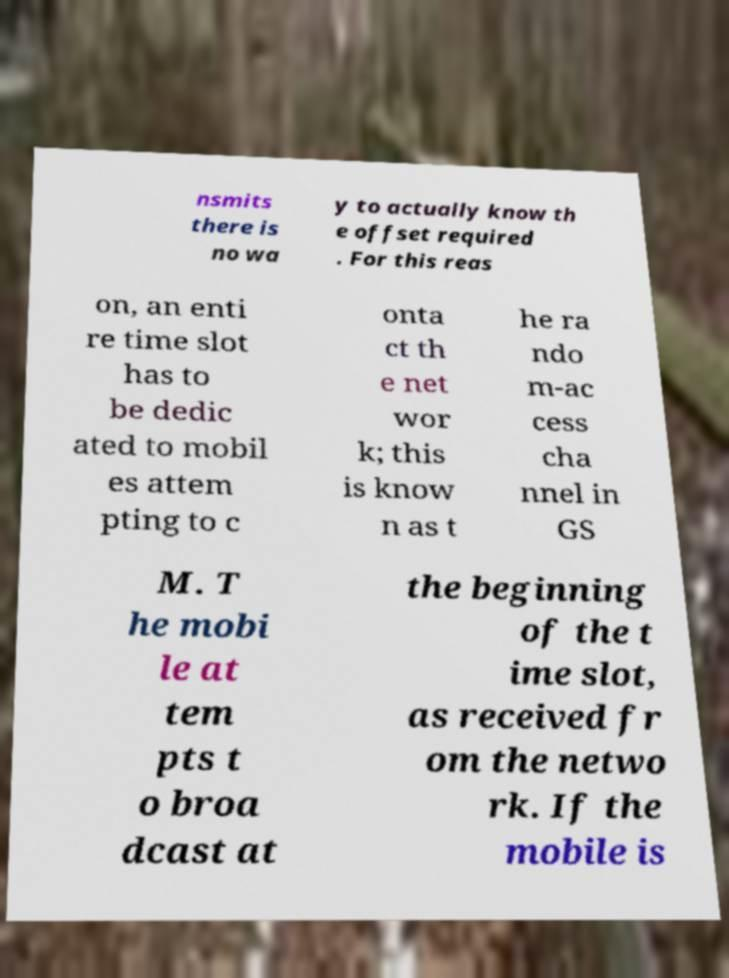For documentation purposes, I need the text within this image transcribed. Could you provide that? nsmits there is no wa y to actually know th e offset required . For this reas on, an enti re time slot has to be dedic ated to mobil es attem pting to c onta ct th e net wor k; this is know n as t he ra ndo m-ac cess cha nnel in GS M. T he mobi le at tem pts t o broa dcast at the beginning of the t ime slot, as received fr om the netwo rk. If the mobile is 